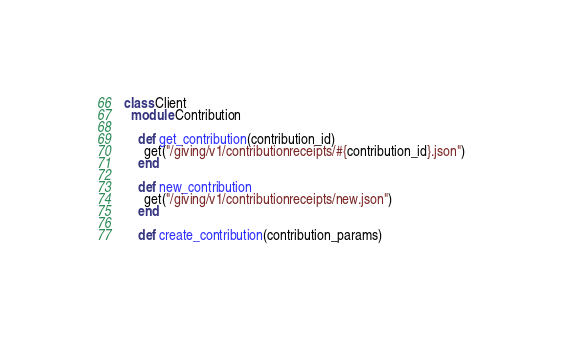<code> <loc_0><loc_0><loc_500><loc_500><_Ruby_>  class Client
    module Contribution

      def get_contribution(contribution_id)
        get("/giving/v1/contributionreceipts/#{contribution_id}.json")
      end

      def new_contribution
        get("/giving/v1/contributionreceipts/new.json")
      end

      def create_contribution(contribution_params)</code> 